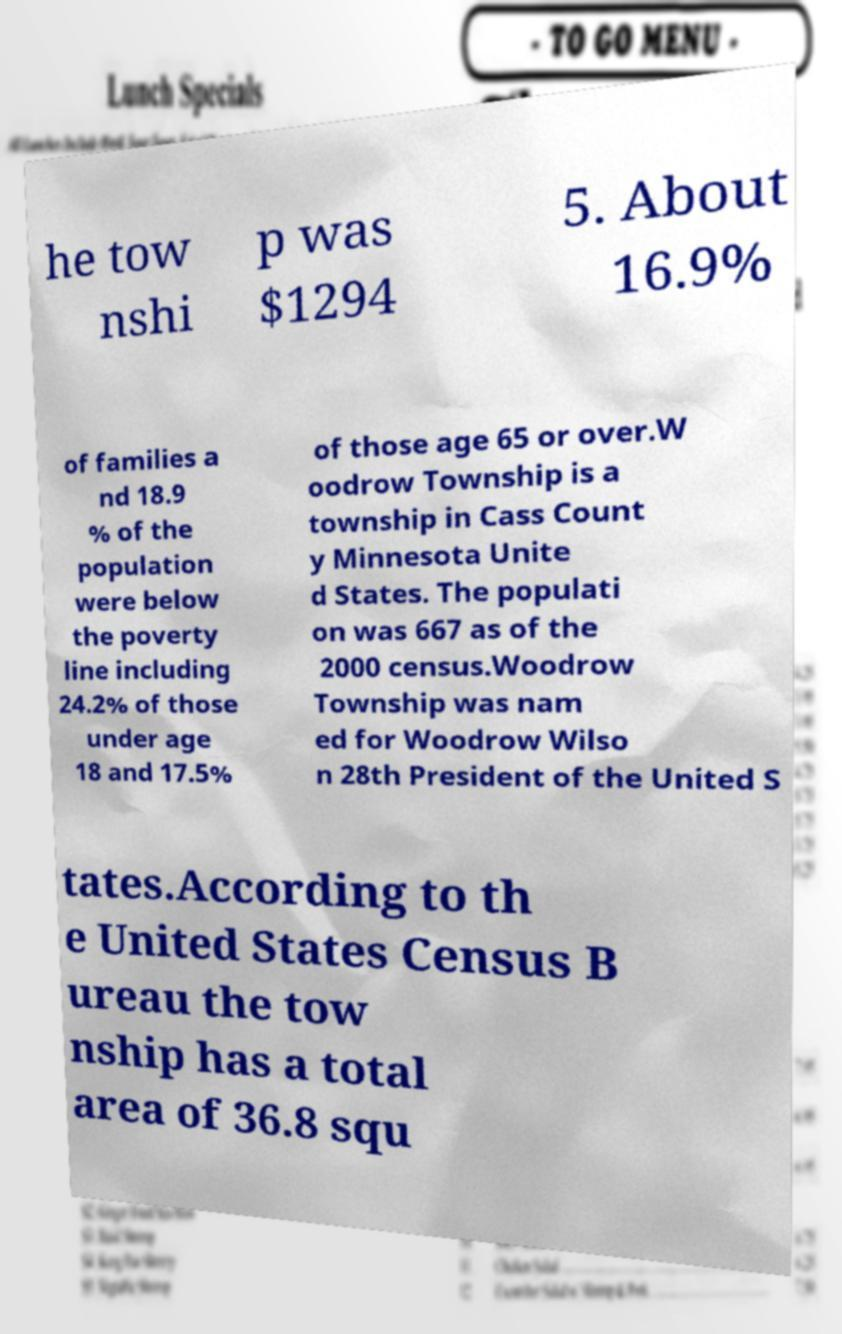Could you extract and type out the text from this image? he tow nshi p was $1294 5. About 16.9% of families a nd 18.9 % of the population were below the poverty line including 24.2% of those under age 18 and 17.5% of those age 65 or over.W oodrow Township is a township in Cass Count y Minnesota Unite d States. The populati on was 667 as of the 2000 census.Woodrow Township was nam ed for Woodrow Wilso n 28th President of the United S tates.According to th e United States Census B ureau the tow nship has a total area of 36.8 squ 